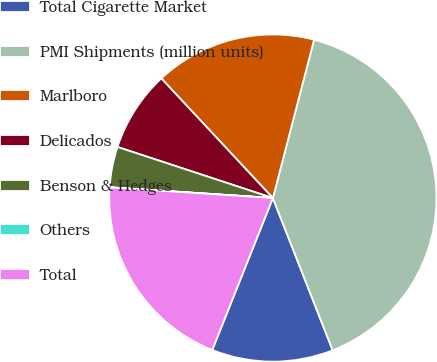Convert chart. <chart><loc_0><loc_0><loc_500><loc_500><pie_chart><fcel>Total Cigarette Market<fcel>PMI Shipments (million units)<fcel>Marlboro<fcel>Delicados<fcel>Benson & Hedges<fcel>Others<fcel>Total<nl><fcel>12.0%<fcel>39.99%<fcel>16.0%<fcel>8.0%<fcel>4.01%<fcel>0.01%<fcel>20.0%<nl></chart> 